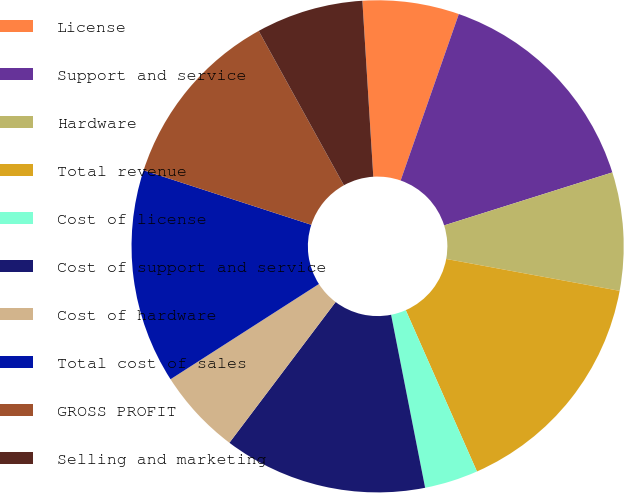<chart> <loc_0><loc_0><loc_500><loc_500><pie_chart><fcel>License<fcel>Support and service<fcel>Hardware<fcel>Total revenue<fcel>Cost of license<fcel>Cost of support and service<fcel>Cost of hardware<fcel>Total cost of sales<fcel>GROSS PROFIT<fcel>Selling and marketing<nl><fcel>6.34%<fcel>14.79%<fcel>7.75%<fcel>15.49%<fcel>3.52%<fcel>13.38%<fcel>5.63%<fcel>14.08%<fcel>11.97%<fcel>7.04%<nl></chart> 